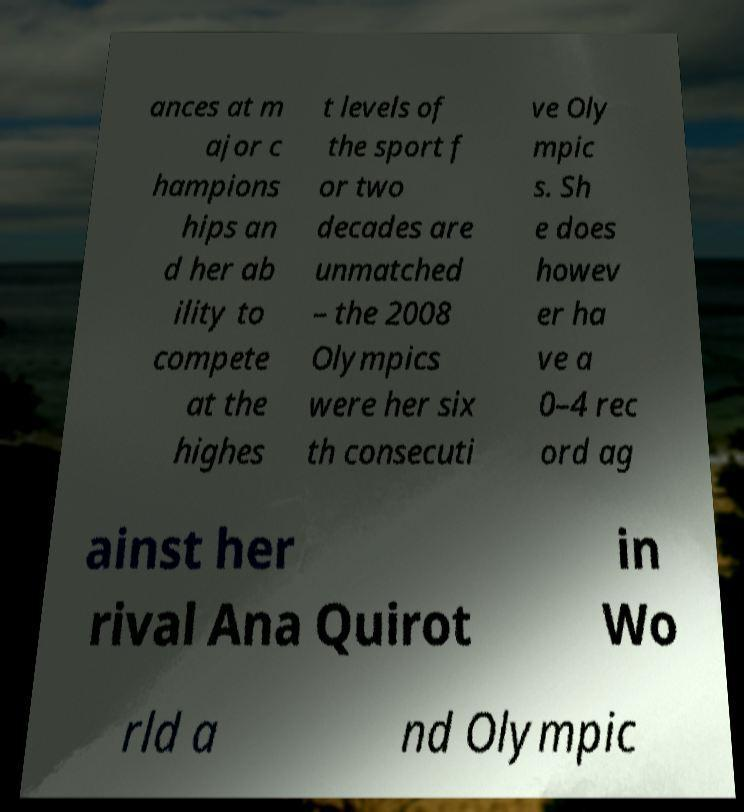I need the written content from this picture converted into text. Can you do that? ances at m ajor c hampions hips an d her ab ility to compete at the highes t levels of the sport f or two decades are unmatched – the 2008 Olympics were her six th consecuti ve Oly mpic s. Sh e does howev er ha ve a 0–4 rec ord ag ainst her rival Ana Quirot in Wo rld a nd Olympic 